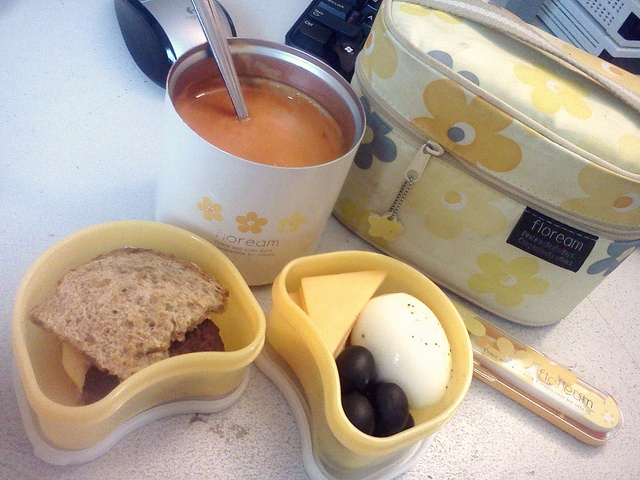Describe the objects in this image and their specific colors. I can see dining table in lightgray, darkgray, tan, gray, and khaki tones, bowl in darkgray, tan, and gray tones, cup in darkgray, lightgray, gray, and tan tones, bowl in darkgray, khaki, tan, beige, and black tones, and sandwich in darkgray, tan, gray, and maroon tones in this image. 